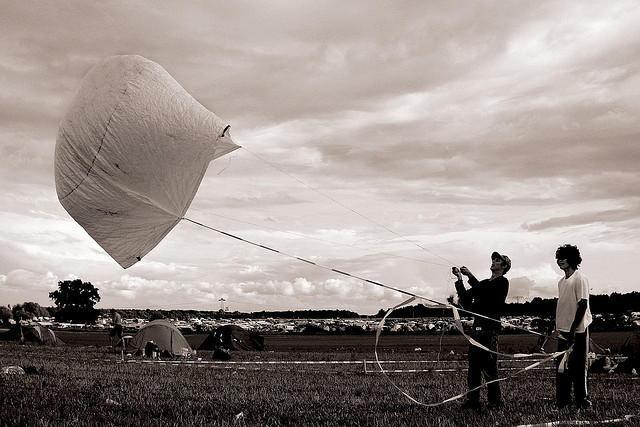How many people are in the picture?
Give a very brief answer. 2. How many people are there?
Give a very brief answer. 2. How many knives can you see?
Give a very brief answer. 0. 